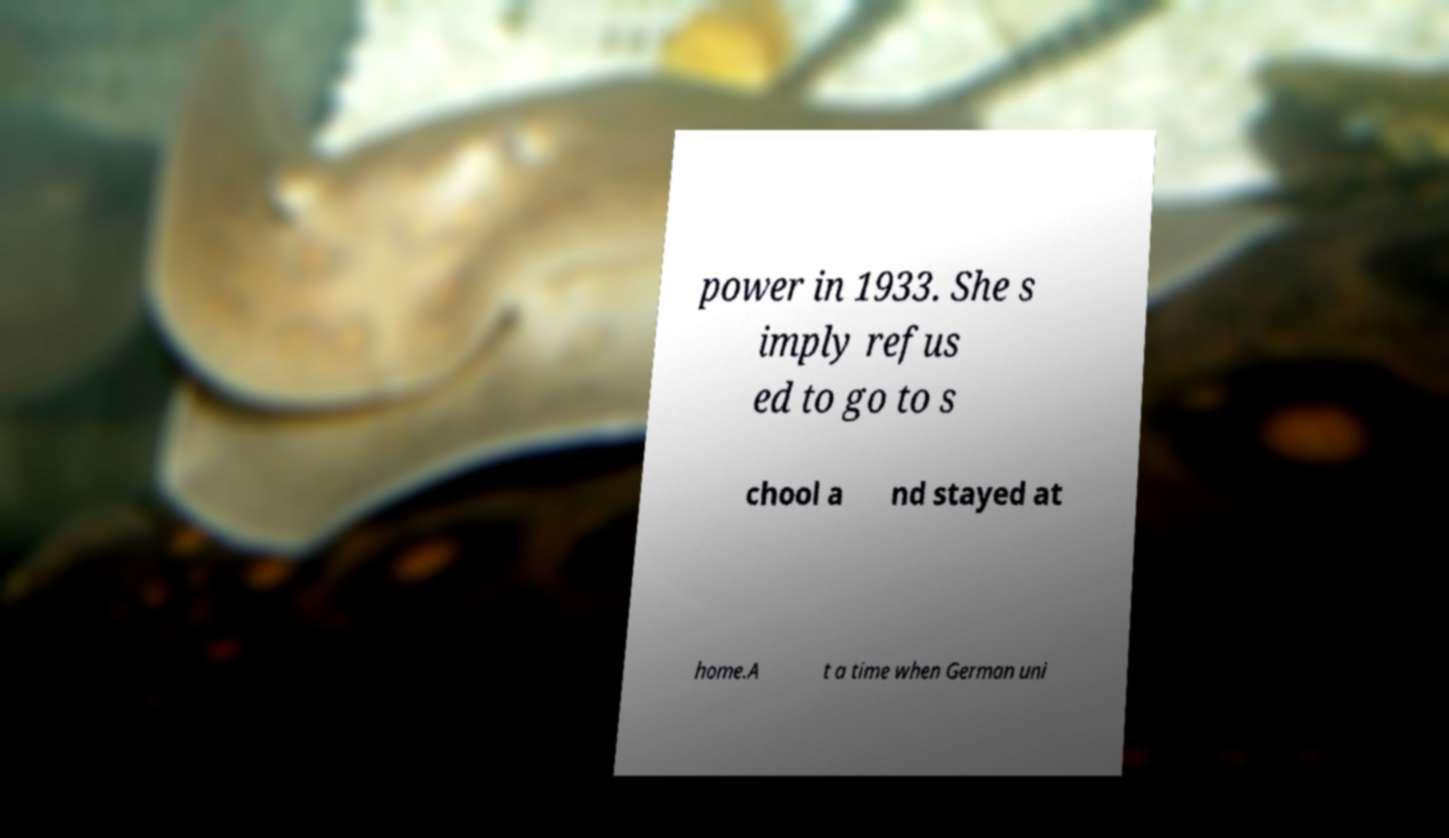Can you read and provide the text displayed in the image?This photo seems to have some interesting text. Can you extract and type it out for me? power in 1933. She s imply refus ed to go to s chool a nd stayed at home.A t a time when German uni 